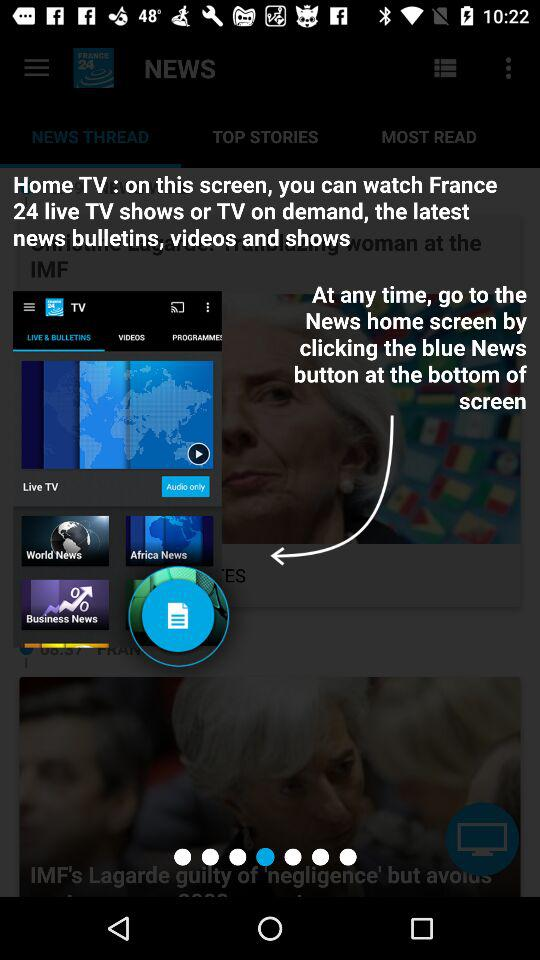What TV channel can we watch on "Home TV"? You can watch the "France 24 live" TV channel on "Home TV". 